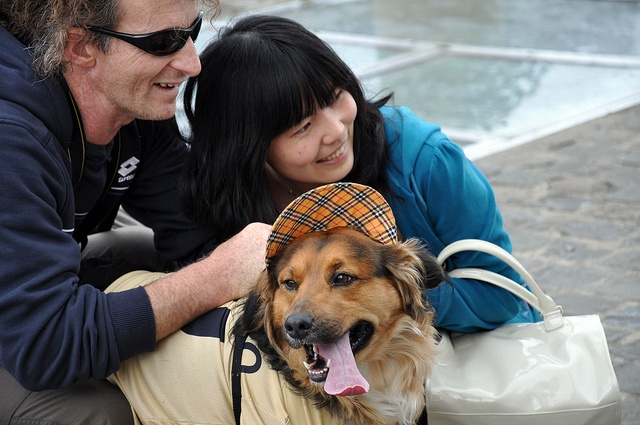Describe the objects in this image and their specific colors. I can see people in black, brown, and gray tones, people in black, lightgray, darkgray, and blue tones, dog in black, tan, gray, and darkgray tones, and handbag in black, lightgray, darkgray, and gray tones in this image. 